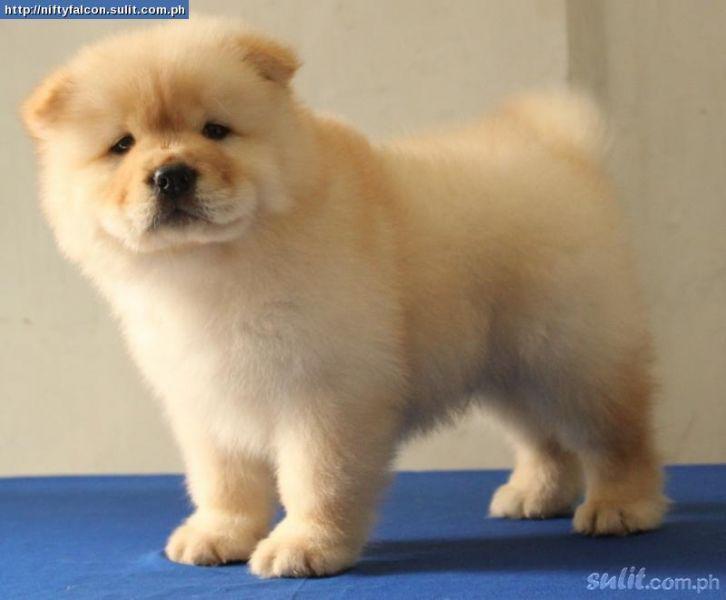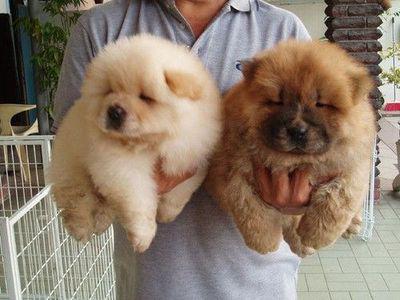The first image is the image on the left, the second image is the image on the right. Assess this claim about the two images: "At least one of the dogs is being handled by a human; either by leash or by grip.". Correct or not? Answer yes or no. Yes. The first image is the image on the left, the second image is the image on the right. For the images shown, is this caption "Exactly one chow dog is standing with all four paws on the ground." true? Answer yes or no. Yes. 